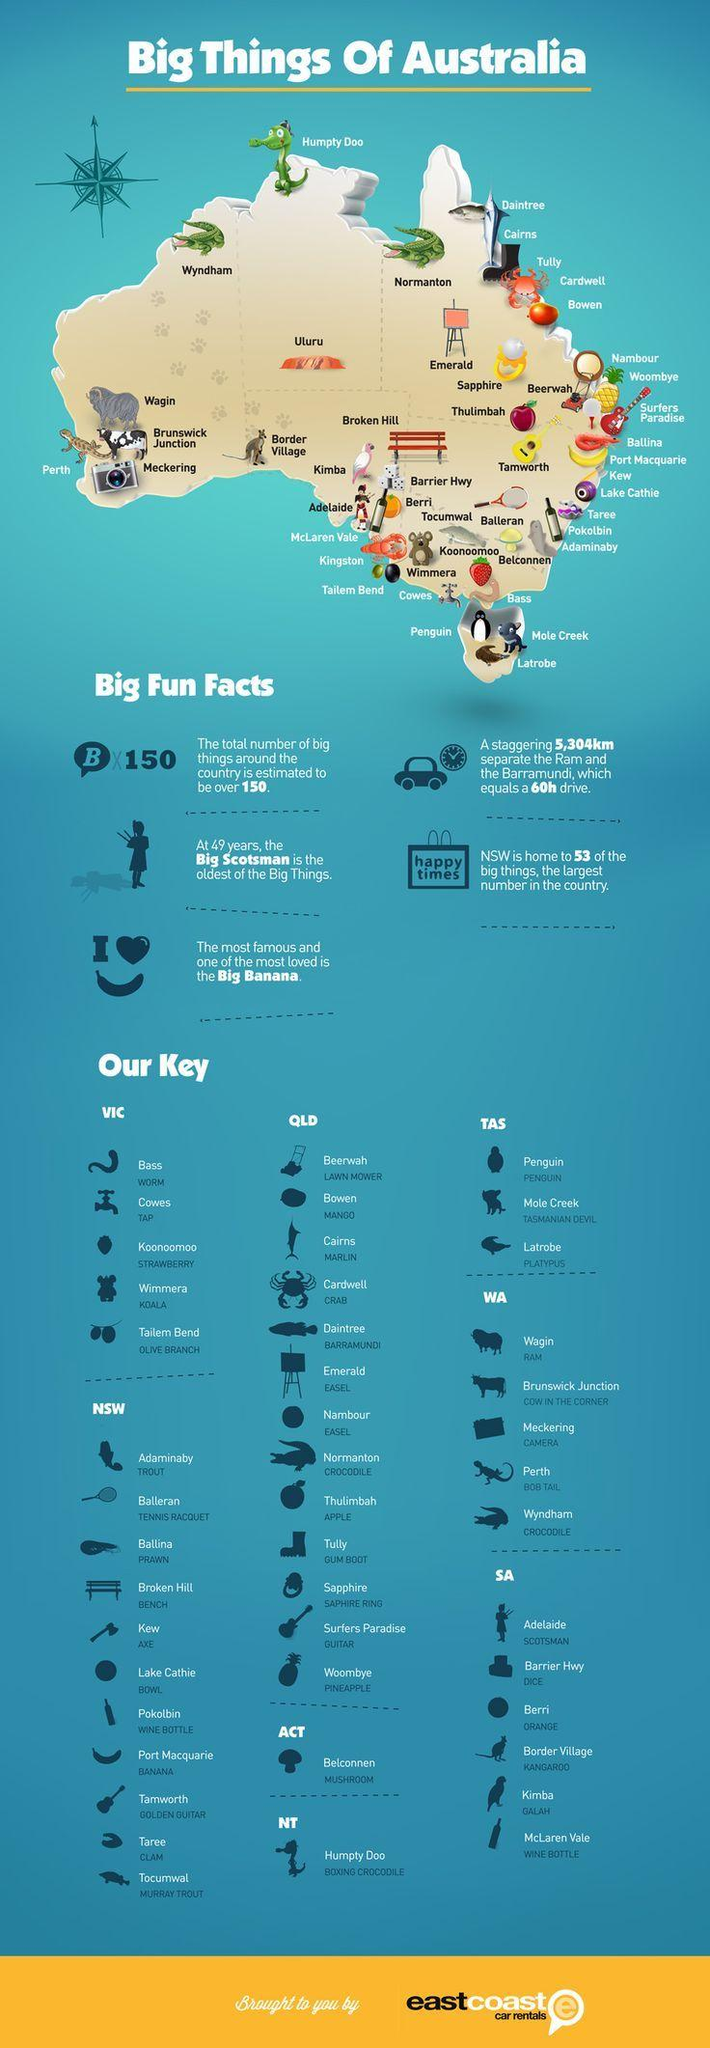Mention a couple of crucial points in this snapshot. The Big Scotsman is the oldest of the 'big things'. 